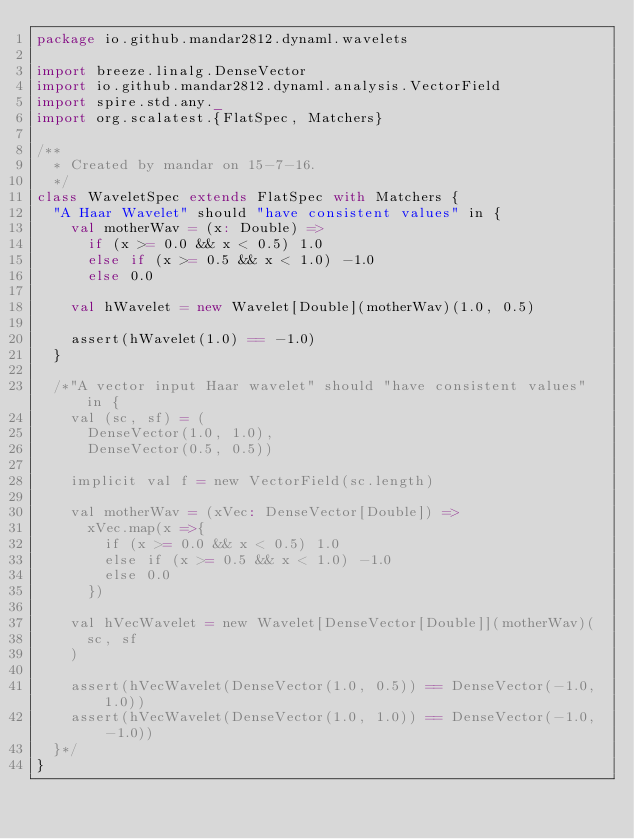Convert code to text. <code><loc_0><loc_0><loc_500><loc_500><_Scala_>package io.github.mandar2812.dynaml.wavelets

import breeze.linalg.DenseVector
import io.github.mandar2812.dynaml.analysis.VectorField
import spire.std.any._
import org.scalatest.{FlatSpec, Matchers}

/**
  * Created by mandar on 15-7-16.
  */
class WaveletSpec extends FlatSpec with Matchers {
  "A Haar Wavelet" should "have consistent values" in {
    val motherWav = (x: Double) =>
      if (x >= 0.0 && x < 0.5) 1.0
      else if (x >= 0.5 && x < 1.0) -1.0
      else 0.0

    val hWavelet = new Wavelet[Double](motherWav)(1.0, 0.5)

    assert(hWavelet(1.0) == -1.0)
  }

  /*"A vector input Haar wavelet" should "have consistent values" in {
    val (sc, sf) = (
      DenseVector(1.0, 1.0),
      DenseVector(0.5, 0.5))

    implicit val f = new VectorField(sc.length)

    val motherWav = (xVec: DenseVector[Double]) =>
      xVec.map(x =>{
        if (x >= 0.0 && x < 0.5) 1.0
        else if (x >= 0.5 && x < 1.0) -1.0
        else 0.0
      })

    val hVecWavelet = new Wavelet[DenseVector[Double]](motherWav)(
      sc, sf
    )

    assert(hVecWavelet(DenseVector(1.0, 0.5)) == DenseVector(-1.0, 1.0))
    assert(hVecWavelet(DenseVector(1.0, 1.0)) == DenseVector(-1.0, -1.0))
  }*/
}
</code> 